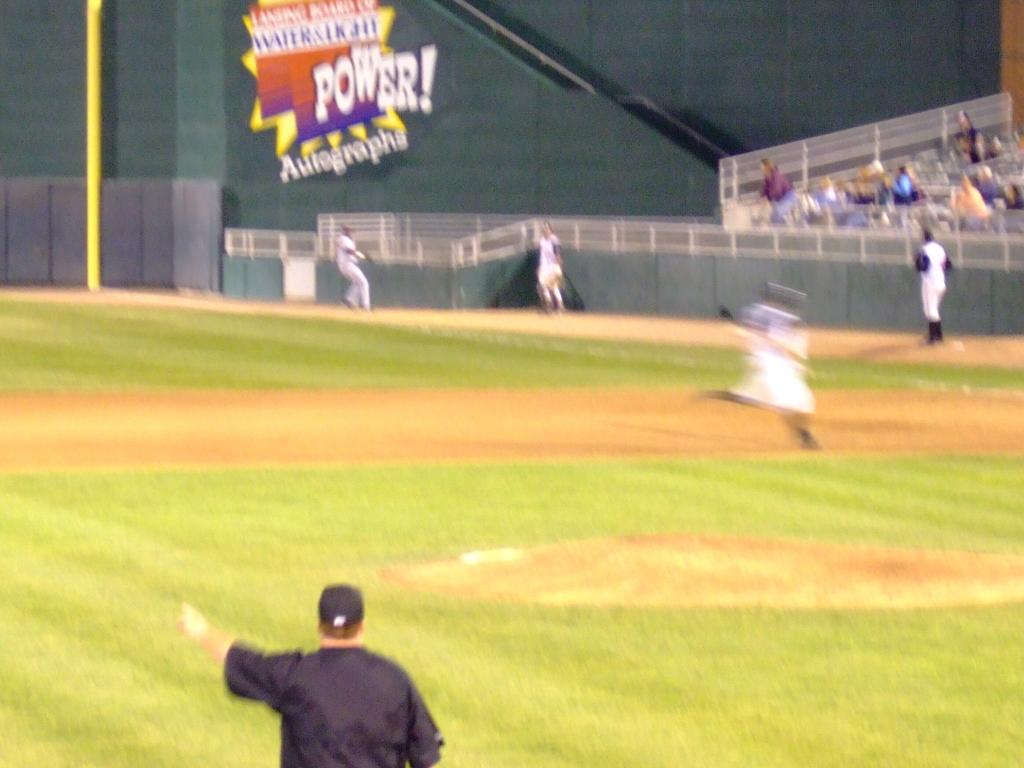<image>
Render a clear and concise summary of the photo. Baseball arena with Power Autograph advertising banner showcased on the side of the boards. 